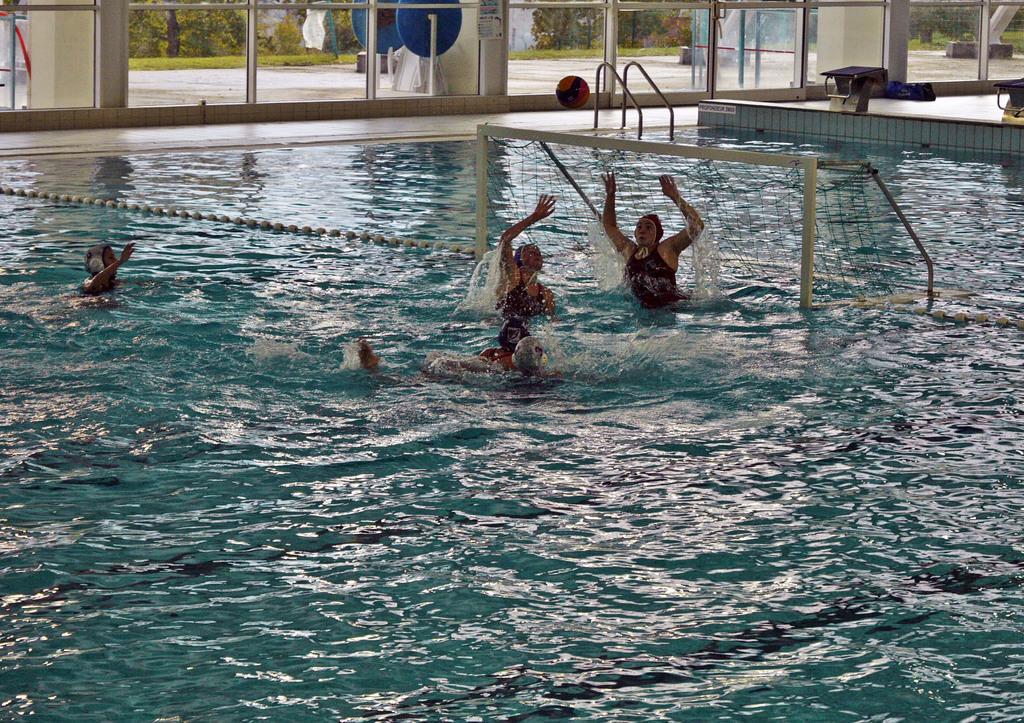Describe this image in one or two sentences. In the picture few people were playing with the ball in the swimming pool, around the swimming pool there are glass doors and behind the doors there are many trees. 